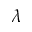Convert formula to latex. <formula><loc_0><loc_0><loc_500><loc_500>\lambda</formula> 